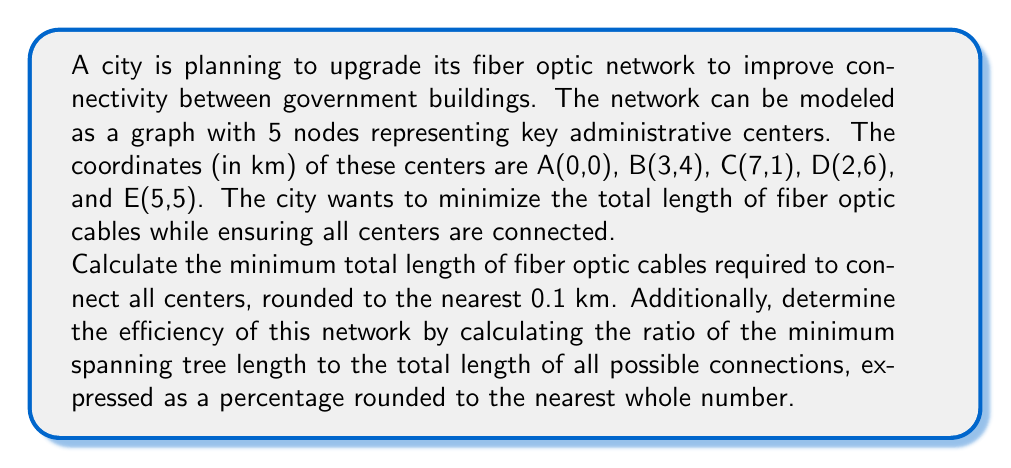Can you solve this math problem? To solve this problem, we'll use concepts from graph theory and coordinate geometry. We'll follow these steps:

1. Calculate distances between all pairs of points
2. Find the minimum spanning tree (MST) using Kruskal's algorithm
3. Calculate the total length of the MST
4. Calculate the total length of all possible connections
5. Compute the network efficiency

Step 1: Calculate distances between all pairs of points

We use the distance formula: $d = \sqrt{(x_2-x_1)^2 + (y_2-y_1)^2}$

AB = $\sqrt{(3-0)^2 + (4-0)^2} = 5$ km
AC = $\sqrt{(7-0)^2 + (1-0)^2} = \sqrt{50} \approx 7.07$ km
AD = $\sqrt{(2-0)^2 + (6-0)^2} = \sqrt{40} \approx 6.32$ km
AE = $\sqrt{(5-0)^2 + (5-0)^2} = 5\sqrt{2} \approx 7.07$ km
BC = $\sqrt{(7-3)^2 + (1-4)^2} = 5$ km
BD = $\sqrt{(2-3)^2 + (6-4)^2} = \sqrt{5} \approx 2.24$ km
BE = $\sqrt{(5-3)^2 + (5-4)^2} = \sqrt{5} \approx 2.24$ km
CD = $\sqrt{(2-7)^2 + (6-1)^2} = \sqrt{50} \approx 7.07$ km
CE = $\sqrt{(5-7)^2 + (5-1)^2} = \sqrt{20} \approx 4.47$ km
DE = $\sqrt{(5-2)^2 + (5-6)^2} = \sqrt{10} \approx 3.16$ km

Step 2: Find the MST using Kruskal's algorithm

Sort edges by length:
BD = BE ≈ 2.24 km
DE ≈ 3.16 km
CE ≈ 4.47 km
AB = BC = 5 km

The MST consists of: BD, BE, DE, CE

Step 3: Calculate the total length of the MST

Total MST length = 2.24 + 2.24 + 3.16 + 4.47 = 12.11 km
Rounded to the nearest 0.1 km: 12.1 km

Step 4: Calculate the total length of all possible connections

Sum of all edge lengths = 5 + 7.07 + 6.32 + 7.07 + 5 + 2.24 + 2.24 + 7.07 + 4.47 + 3.16 = 49.64 km

Step 5: Compute the network efficiency

Efficiency = (MST length / Total possible connections length) * 100
= (12.11 / 49.64) * 100 ≈ 24.39%
Rounded to the nearest whole number: 24%
Answer: The minimum total length of fiber optic cables required is 12.1 km, and the network efficiency is 24%. 